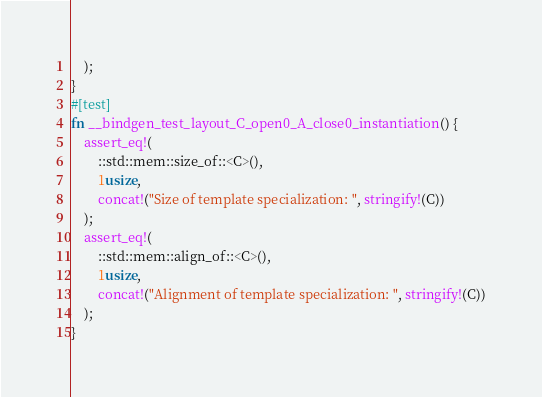Convert code to text. <code><loc_0><loc_0><loc_500><loc_500><_Rust_>    );
}
#[test]
fn __bindgen_test_layout_C_open0_A_close0_instantiation() {
    assert_eq!(
        ::std::mem::size_of::<C>(),
        1usize,
        concat!("Size of template specialization: ", stringify!(C))
    );
    assert_eq!(
        ::std::mem::align_of::<C>(),
        1usize,
        concat!("Alignment of template specialization: ", stringify!(C))
    );
}
</code> 